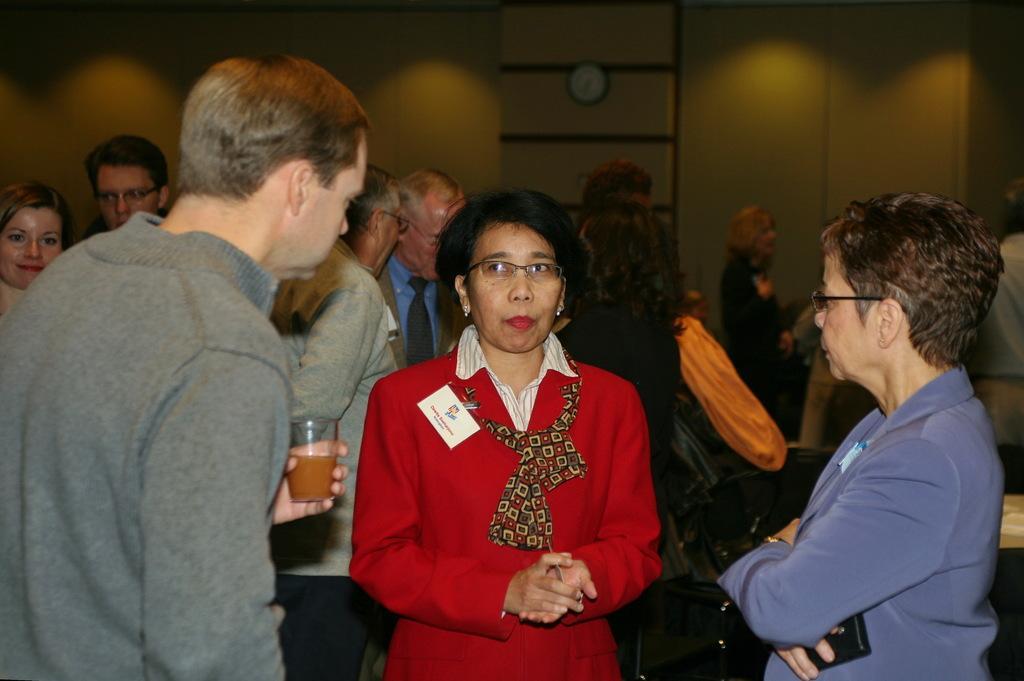How would you summarize this image in a sentence or two? In this picture there is a woman who is wearing red dress. Beside her there is a man who is wearing spectacle, suit and holding a mobile phone. Beside her there is a man who is holding a wine glass. In the back I can see some peoples were standing near to the table and wall. At the top there is a wall clock which is placed on the wall. Beside that I can see the light beams. On the left background there is a woman who is smiling. 